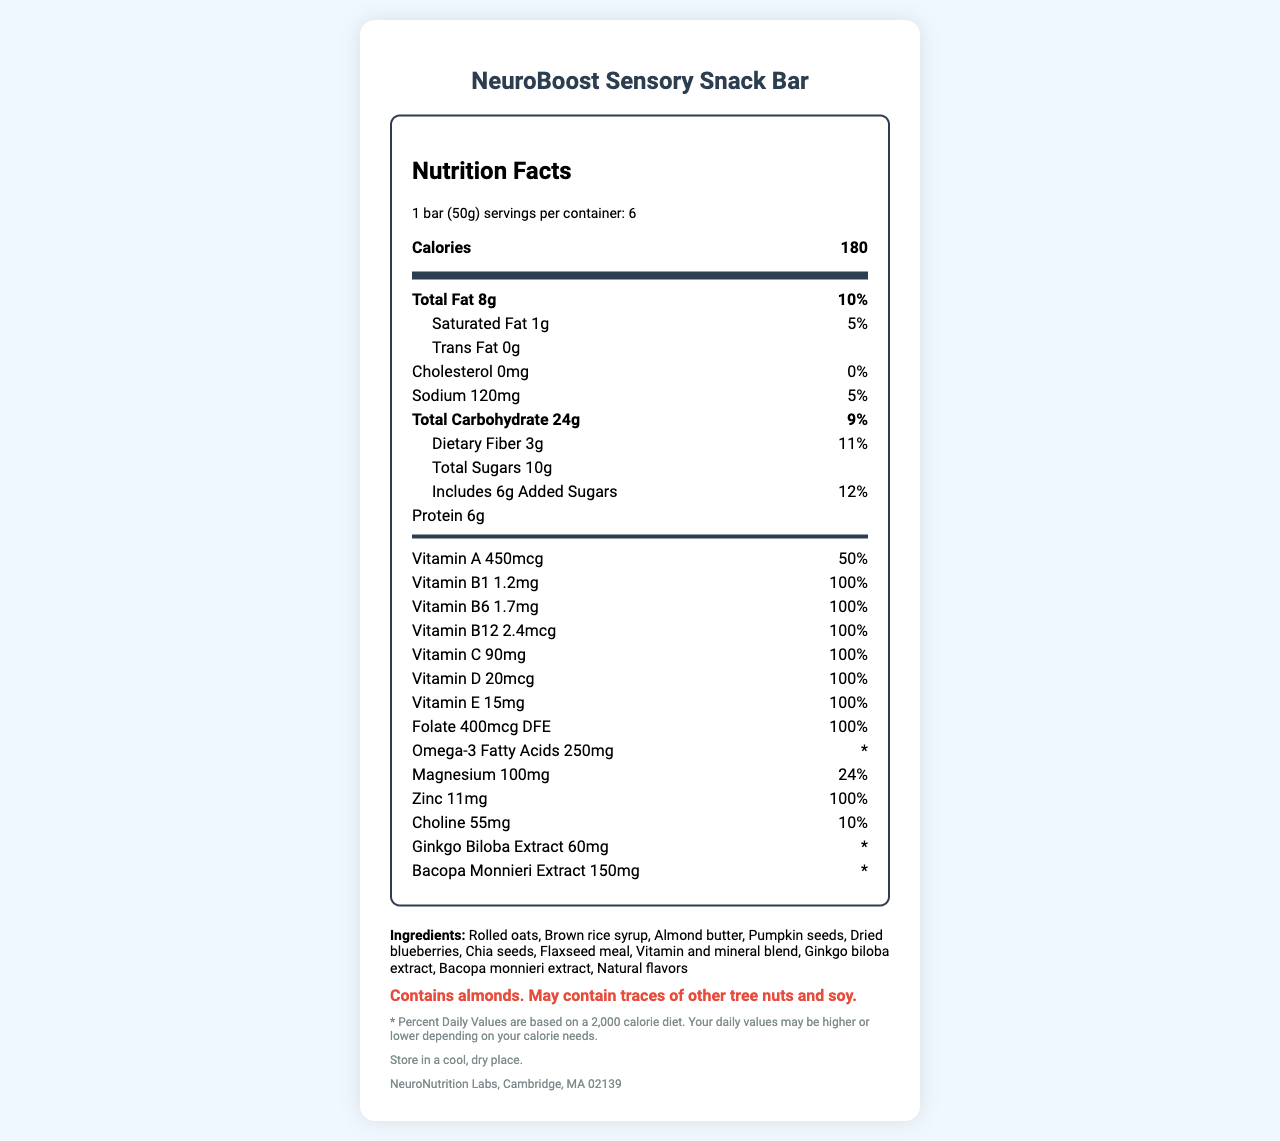what is the serving size of the NeuroBoost Sensory Snack Bar? The serving size is explicitly stated as "1 bar (50g)".
Answer: 1 bar (50g) how many servings are there per container? The document specifies that there are "6 servings per container".
Answer: 6 what is the total carbohydrate content per serving? The total carbohydrate content is listed as "24g" per serving.
Answer: 24g how much protein does one bar contain? The protein content for one serving is given as "6g".
Answer: 6g does the snack bar contain any trans fat? The document lists "Trans Fat" as "0g".
Answer: No which vitamin is present at 50% of the daily value? A. Vitamin A B. Vitamin C C. Vitamin E D. Vitamin D The document shows "Vitamin A: 450mcg (50%)", while other vitamins reach 100% of the daily value.
Answer: A how much vitamin B6 is in one bar? The amount of vitamin B6 is specified as "1.7mg".
Answer: 1.7mg is this snack bar suitable for a low-sodium diet? The sodium content is relatively low at "120mg" per serving and 5% of the daily value.
Answer: Yes what are the main ingredients in the snack bar? A. Rolled oats, chia seeds, flaxseed meal B. Brown rice syrup, pumpkin seeds, dried blueberries C. Both A and B D. None of the above The list of ingredients includes rolled oats, chia seeds, flaxseed meal, brown rice syrup, pumpkin seeds, dried blueberries, among others.
Answer: C does the snack bar contain any cholesterol? The cholesterol content is listed as "0mg" in the document.
Answer: No can the amount of Bacopa Monnieri Extract be determined from the document? The document lists "Bacopa Monnieri Extract 150mg".
Answer: Yes, it is 150mg what is the main idea of this document? The document outlines key nutrition facts, including the macronutrient content, vitamins and minerals, ingredients, and allergen information, aiming to highlight the product's role in enhancing sensory perception and neural plasticity.
Answer: It provides detailed nutritional information about the NeuroBoost Sensory Snack Bar. how much magnesium does one bar provide? The document specifies the magnesium content as "100mg".
Answer: 100mg is there enough information to determine the total fiber content for the entire container? The document provides the fiber content per serving, but not total fiber for all servings combined.
Answer: No who is the manufacturer of this snack? The document states the manufacturer as "NeuroNutrition Labs, Cambridge, MA 02139".
Answer: NeuroNutrition Labs, Cambridge, MA 02139 what allergen does the snack bar contain? The allergen information indicates that the product contains almonds and may contain traces of other tree nuts and soy.
Answer: Almonds why might someone with higher daily calorie needs find the % daily values on this label less applicable? The disclaimer notes that the % daily values are based on a 2,000 calorie diet and suggests individual needs may vary.
Answer: The % daily values are based on a 2,000 calorie diet, which might not align with their higher calorie requirements. 